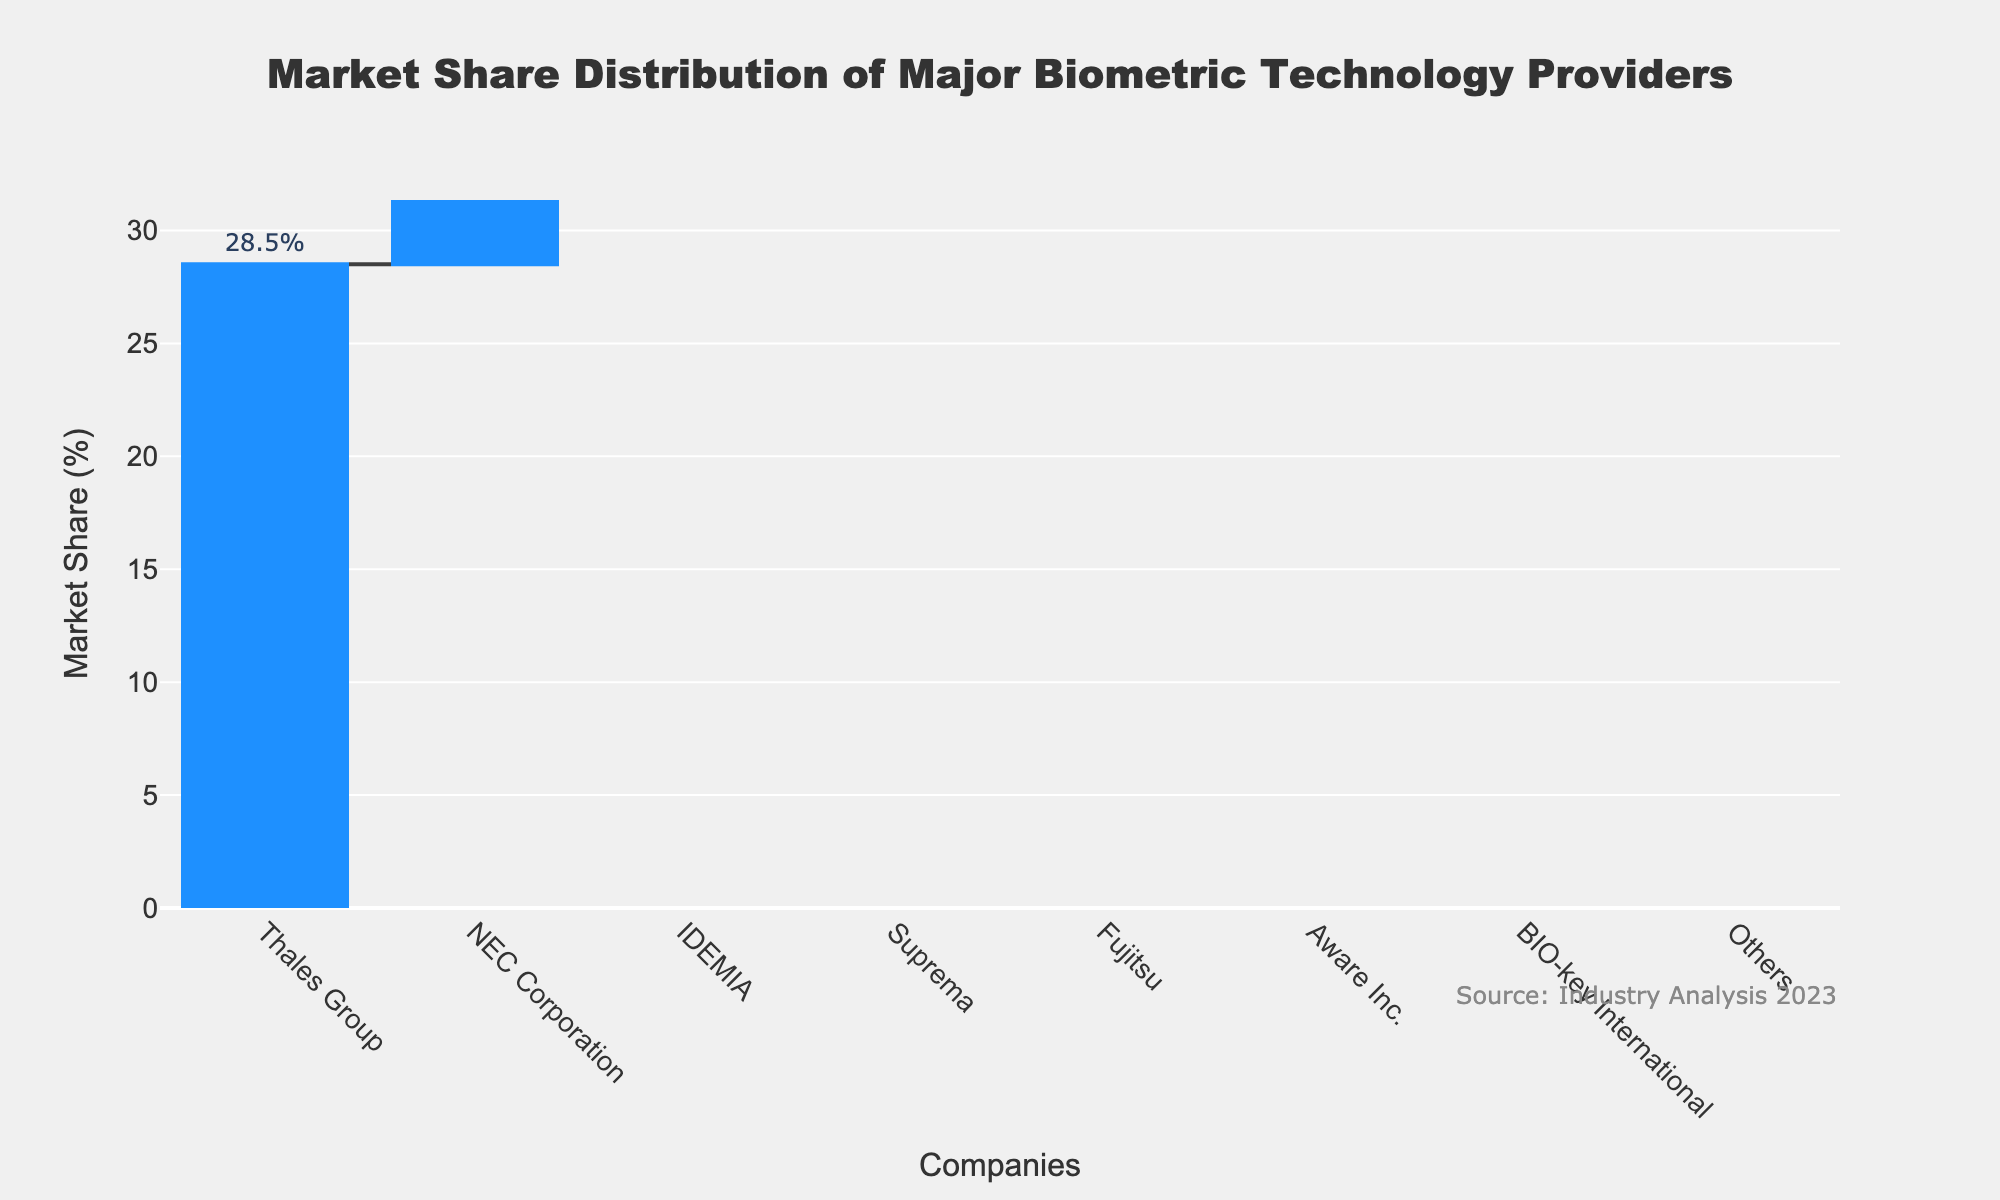What is the market share of the leading company? We look at the tallest bar in the chart. It belongs to Thales Group with a market share of 28.5%.
Answer: 28.5% How many companies are represented in the chart? Count the number of distinct companies listed along the x-axis. There are 8 companies represented.
Answer: 8 What is the combined market share of the top three companies? The top three companies are Thales Group, NEC Corporation, and IDEMIA. Sum their market shares: 28.5% + 21.3% + 18.7% = 68.5%.
Answer: 68.5% Which company has the smallest market share, and what is it? Identify the shortest bar or the last label on the x-axis. The smallest market share belongs to "Others" with 1.4%.
Answer: Others, 1.4% How does the market share of NEC Corporation compare to Suprema? NEC Corporation has a market share of 21.3%, and Suprema has 12.4%. NEC Corporation's market share is higher than Suprema's.
Answer: NEC Corporation's market share is higher Which companies have a market share greater than 10%? Identify all bars that extend above the 10% mark on the y-axis. The companies with more than 10% market share are Thales Group, NEC Corporation, IDEMIA, and Suprema.
Answer: Thales Group, NEC Corporation, IDEMIA, Suprema Is the market share of Aware Inc. greater or less than BIO-key International? Compare the heights of the bars for Aware Inc. and BIO-key International. Aware Inc. has a market share of 5.6%, which is greater than BIO-key International's 3.2%.
Answer: Aware Inc.'s market share is greater What is the average market share of all the companies listed? Add up the market shares of all companies and divide by the number of companies: (28.5% + 21.3% + 18.7% + 12.4% + 8.9% + 5.6% + 3.2% + 1.4%) / 8 = 100% / 8 = 12.5%.
Answer: 12.5% Which company has nearly half the market share of Thales Group? Divide Thales Group's market share by 2: 28.5% / 2 = 14.25%. Look for the company with a market share close to 14.25%. Suprema has a market share of 12.4%, which is the closest.
Answer: Suprema What is the sum of the market shares of the companies ranked fourth and fifth? The fourth and fifth companies are Suprema and Fujitsu. Sum their market shares: 12.4% + 8.9% = 21.3%.
Answer: 21.3% 